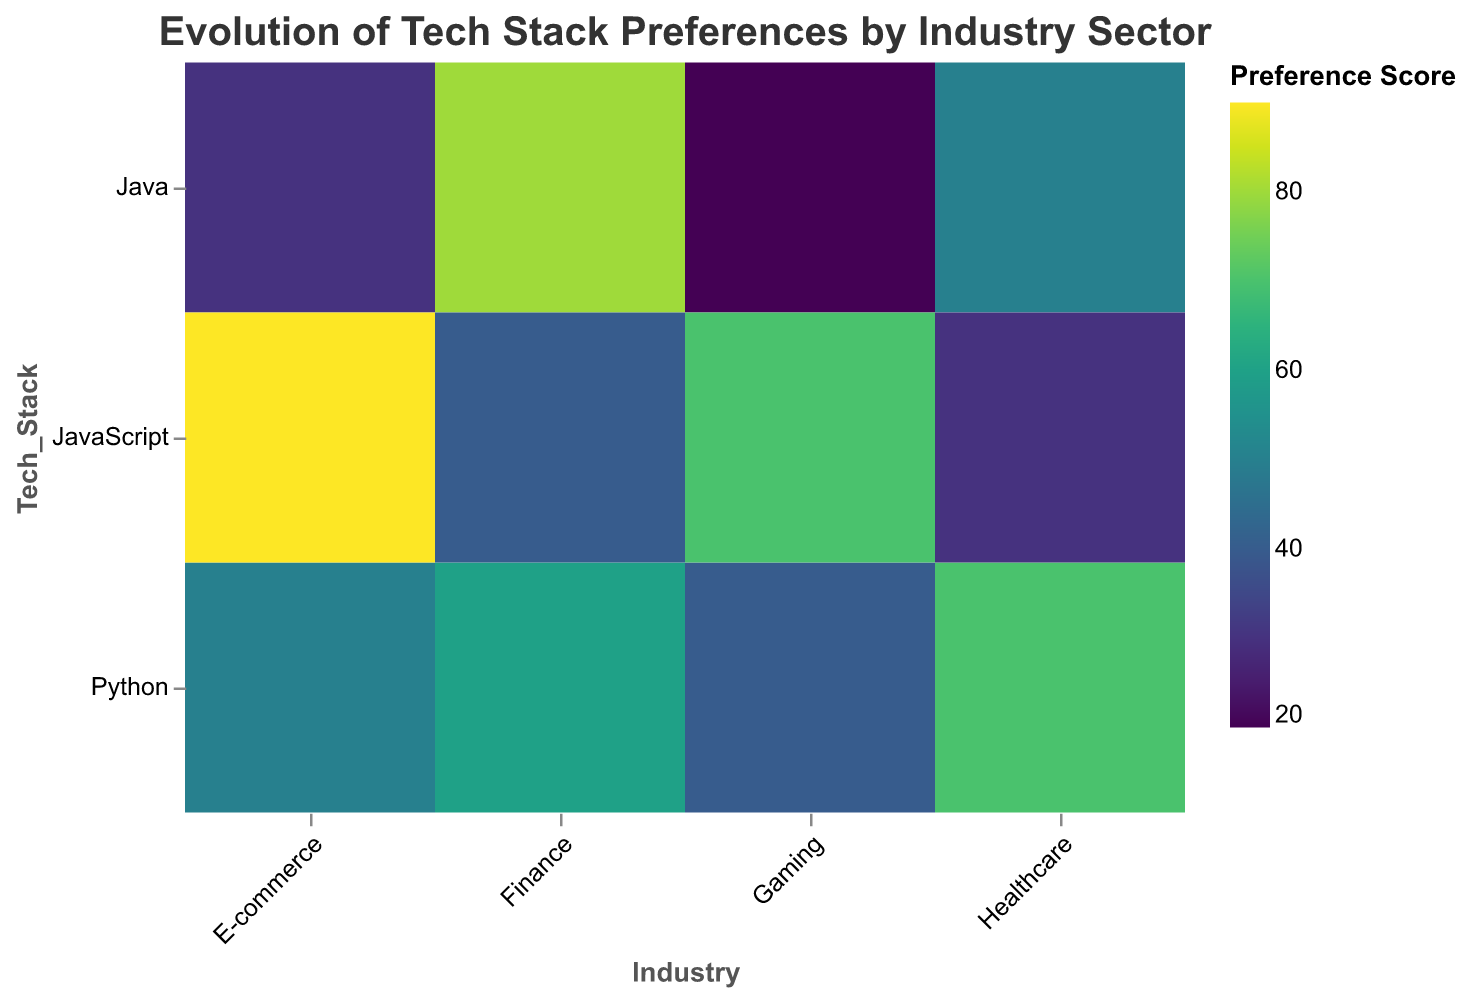What is the most preferred tech stack in the Finance industry? Looking at the "Finance" column, you can see that the highest preference score is 80, which corresponds to "Java".
Answer: Java Which industry shows the highest preference score for JavaScript? Identify the highest value in the "JavaScript" row. The value is 90 in the "E-commerce" column.
Answer: E-commerce Between the Healthcare and Gaming industries, which one has a higher preference score for Python? Compare the values for "Python" in the "Healthcare" (70) and "Gaming" (40) columns. Healthcare has a higher score.
Answer: Healthcare What is the difference in preference scores for Java between the Finance and Gaming industries? The preference scores for "Java" are 80 (Finance) and 20 (Gaming). The difference is 80 - 20 = 60.
Answer: 60 What is the least preferred tech stack in the Gaming industry? Look for the lowest score in the "Gaming" column, which is 20 for "Java".
Answer: Java Compare the Python preference scores between Finance, E-commerce, and Healthcare. Which is the highest? The scores are 60 (Finance), 50 (E-commerce), and 70 (Healthcare). The highest is 70.
Answer: Healthcare What is the title of the heatmap? The title is written at the top of the heatmap and reads "Evolution of Tech Stack Preferences by Industry Sector".
Answer: Evolution of Tech Stack Preferences by Industry Sector Which tech stack has the most similar preference scores across all industries? Look for similar values across the columns for each tech stack. "Python" (60, 70, 50, 40) has relatively close scores compared to others.
Answer: Python How does the preference score for Python in Healthcare compare to JavaScript in E-commerce? The preference score for "Python" in "Healthcare" is 70, while for "JavaScript" in "E-commerce" it is 90. 90 is greater than 70.
Answer: JavaScript in E-commerce is higher What is the sum of the Preference Scores for JavaScript across all industries? Sum the values for "JavaScript": 40 (Finance) + 30 (Healthcare) + 90 (E-commerce) + 70 (Gaming) = 230.
Answer: 230 